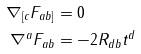<formula> <loc_0><loc_0><loc_500><loc_500>\nabla _ { [ c } F _ { a b ] } & = 0 \\ \nabla ^ { a } F _ { a b } & = - 2 R _ { d b } t ^ { d }</formula> 